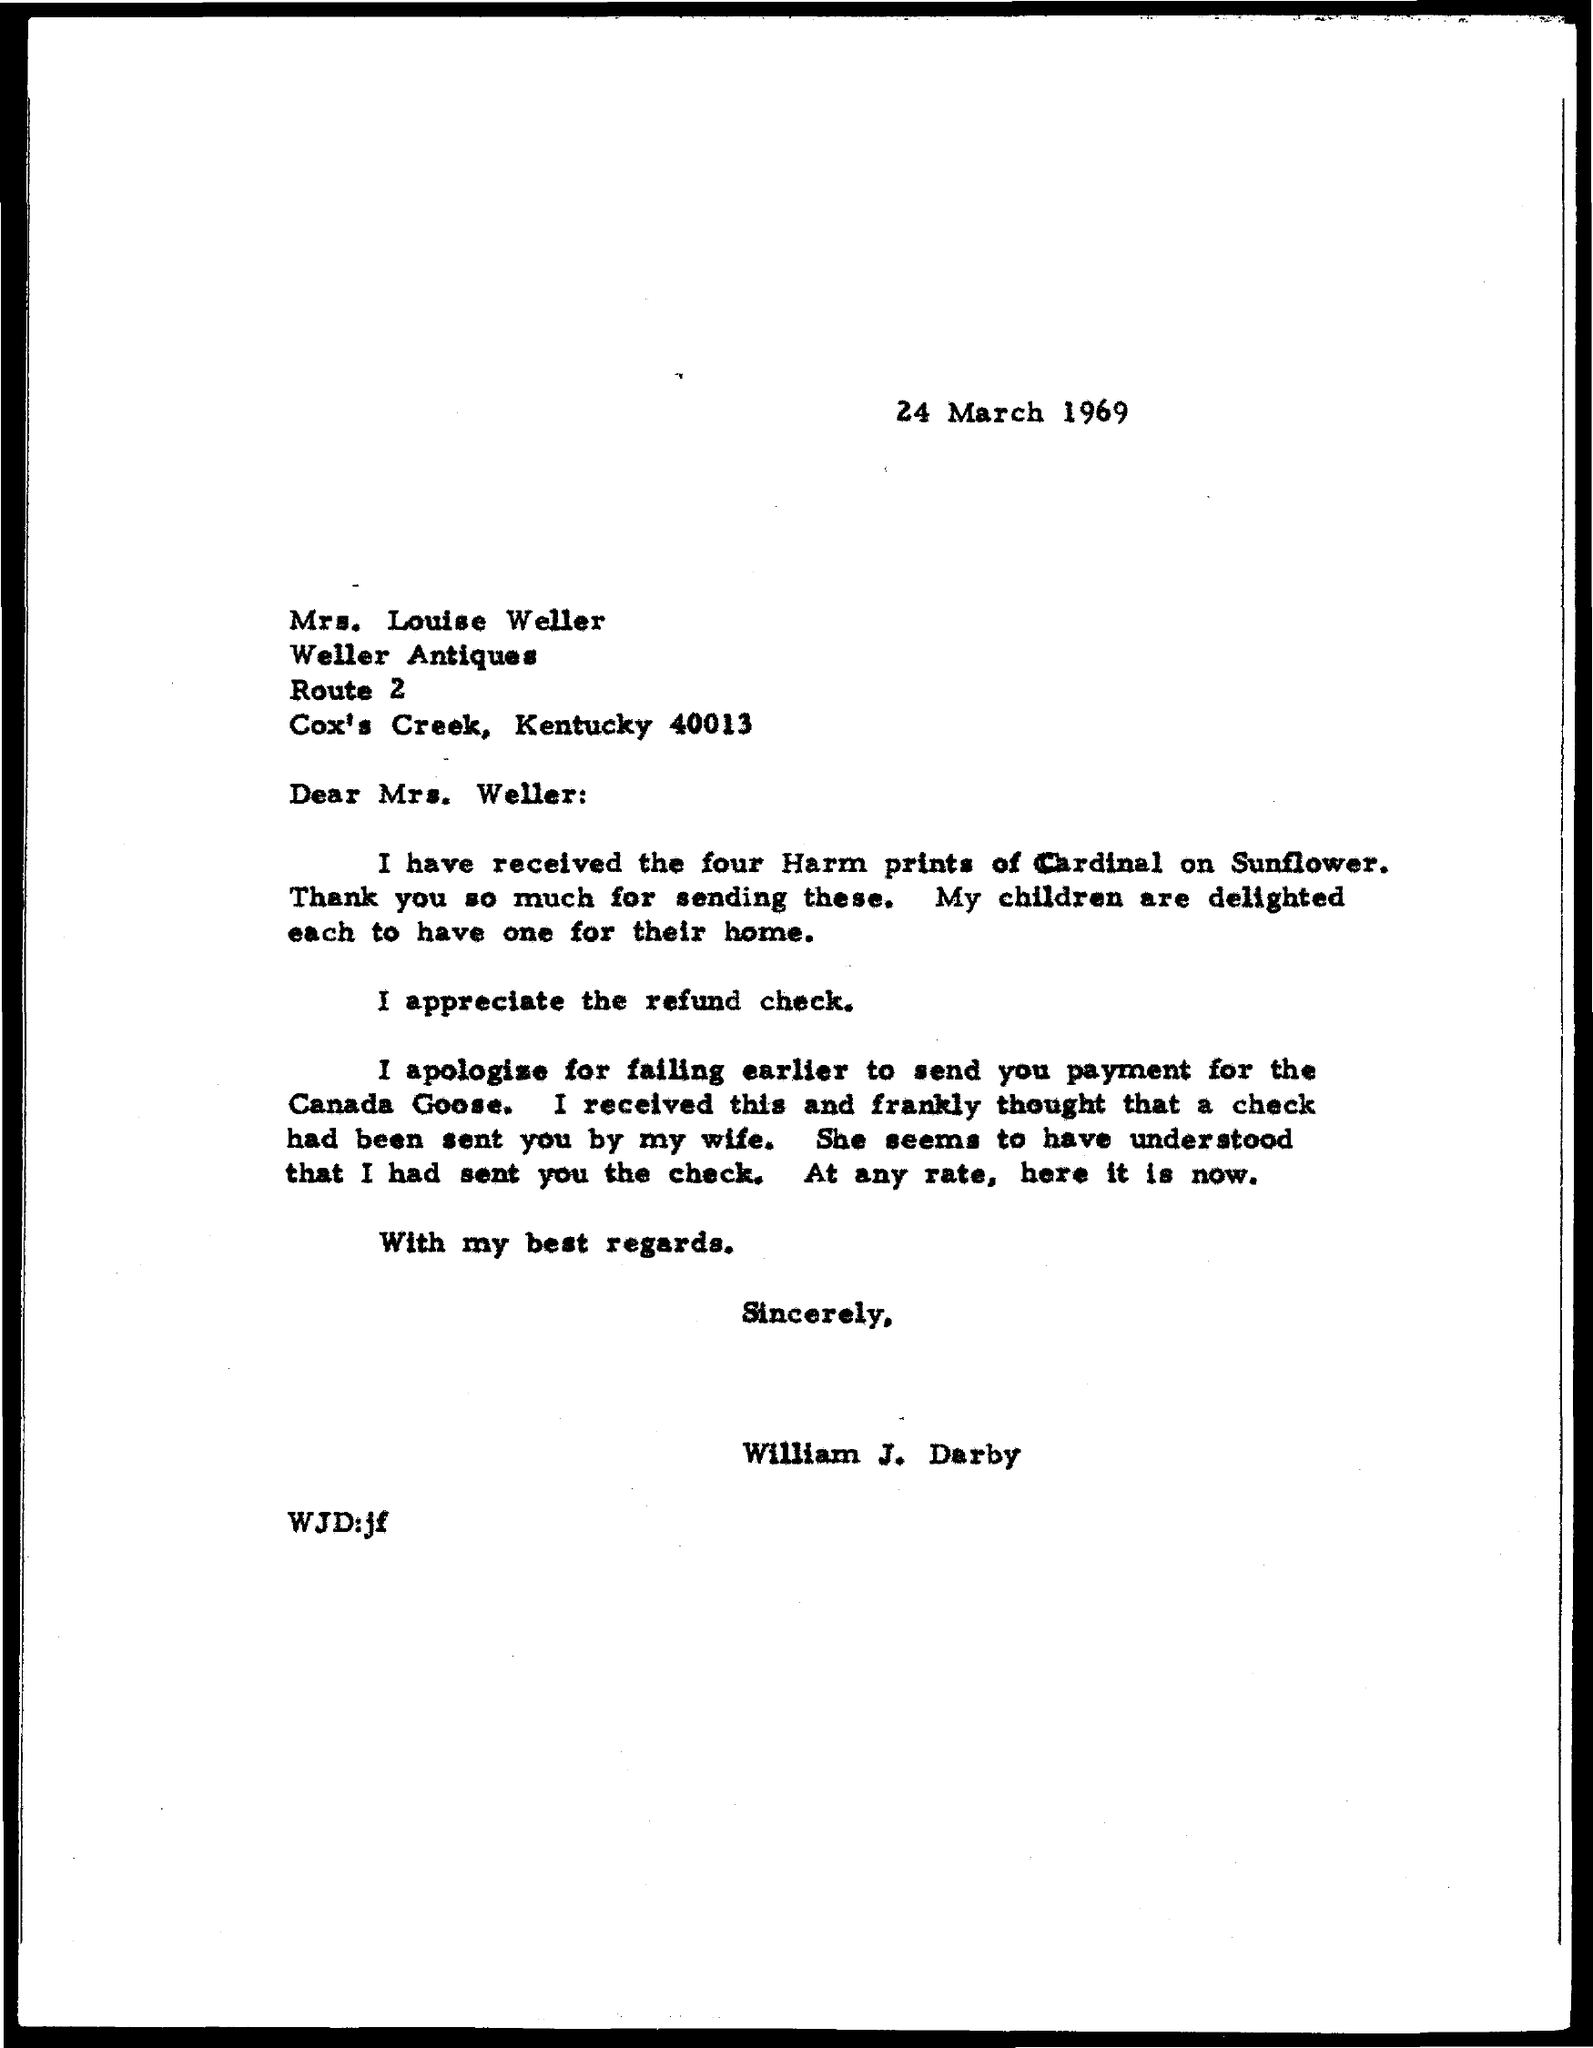What is the date mentioned?
Your answer should be very brief. 24 march 1969. 